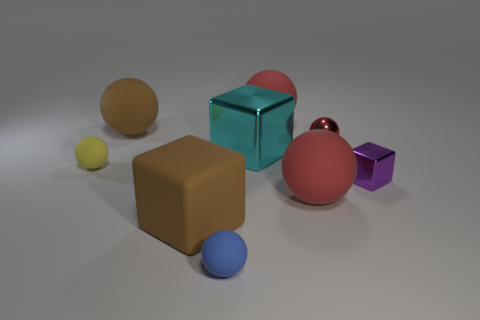Subtract all gray cylinders. How many red spheres are left? 3 Subtract all brown balls. How many balls are left? 5 Subtract all large brown spheres. How many spheres are left? 5 Subtract all blue balls. Subtract all red cylinders. How many balls are left? 5 Add 1 large purple matte cylinders. How many objects exist? 10 Subtract all spheres. How many objects are left? 3 Add 4 brown matte balls. How many brown matte balls are left? 5 Add 7 large balls. How many large balls exist? 10 Subtract 0 gray cylinders. How many objects are left? 9 Subtract all small purple objects. Subtract all small red metal spheres. How many objects are left? 7 